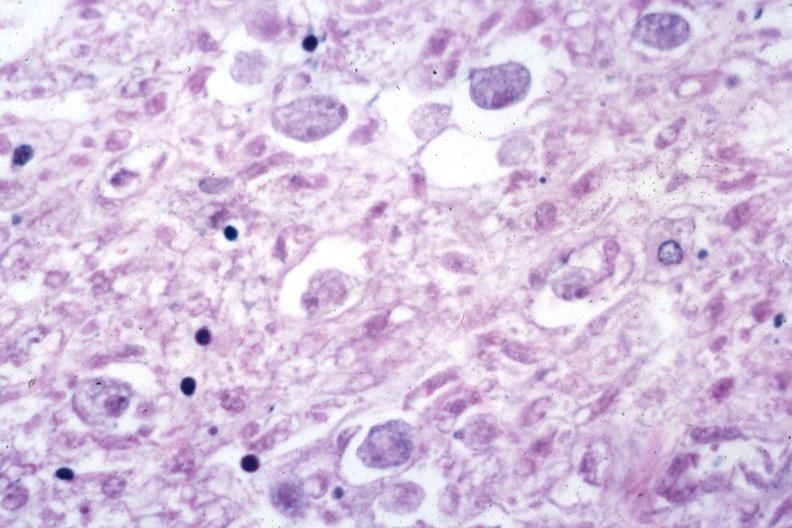what is present?
Answer the question using a single word or phrase. Gastrointestinal 